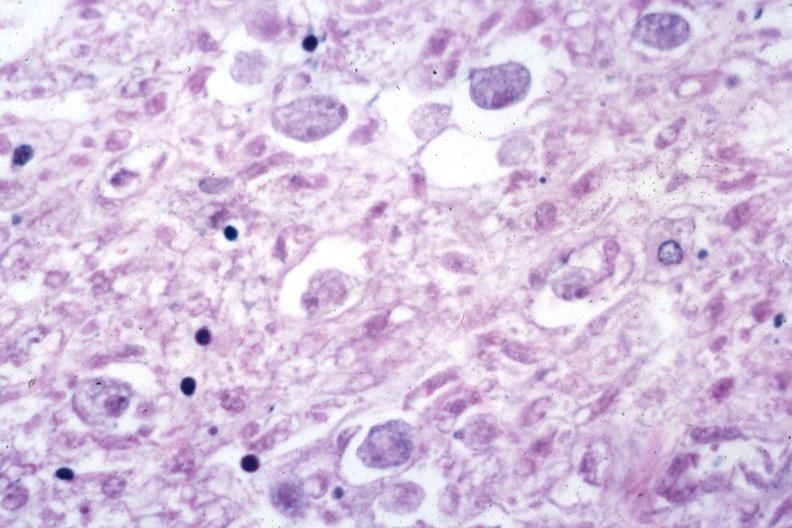what is present?
Answer the question using a single word or phrase. Gastrointestinal 